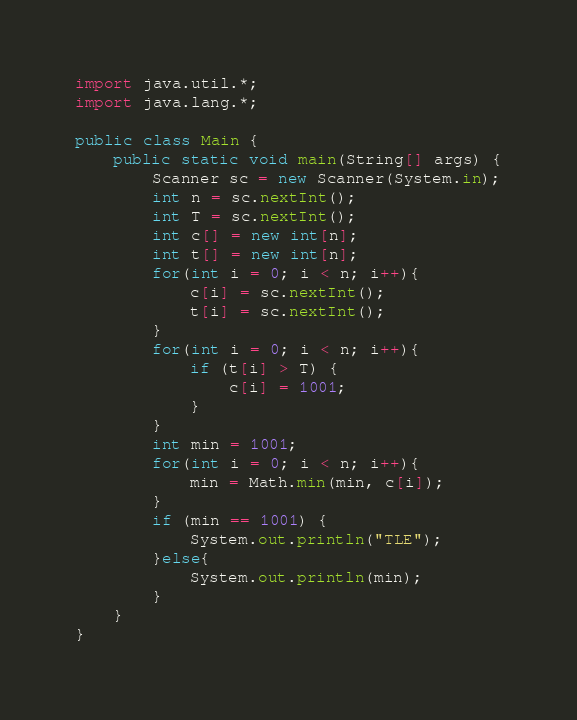Convert code to text. <code><loc_0><loc_0><loc_500><loc_500><_Java_>import java.util.*;
import java.lang.*;

public class Main {
    public static void main(String[] args) {
        Scanner sc = new Scanner(System.in);
        int n = sc.nextInt();
        int T = sc.nextInt();
        int c[] = new int[n];
        int t[] = new int[n];
        for(int i = 0; i < n; i++){
            c[i] = sc.nextInt();
            t[i] = sc.nextInt();
        }
        for(int i = 0; i < n; i++){
            if (t[i] > T) {
                c[i] = 1001;
            }
        }
        int min = 1001;
        for(int i = 0; i < n; i++){
            min = Math.min(min, c[i]);
        }
        if (min == 1001) {
            System.out.println("TLE");
        }else{
            System.out.println(min);
        }
    }
}
</code> 